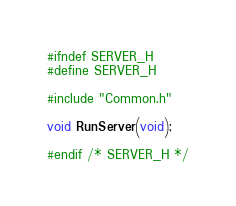Convert code to text. <code><loc_0><loc_0><loc_500><loc_500><_C_>#ifndef SERVER_H
#define SERVER_H

#include "Common.h"

void RunServer(void);

#endif /* SERVER_H */
</code> 